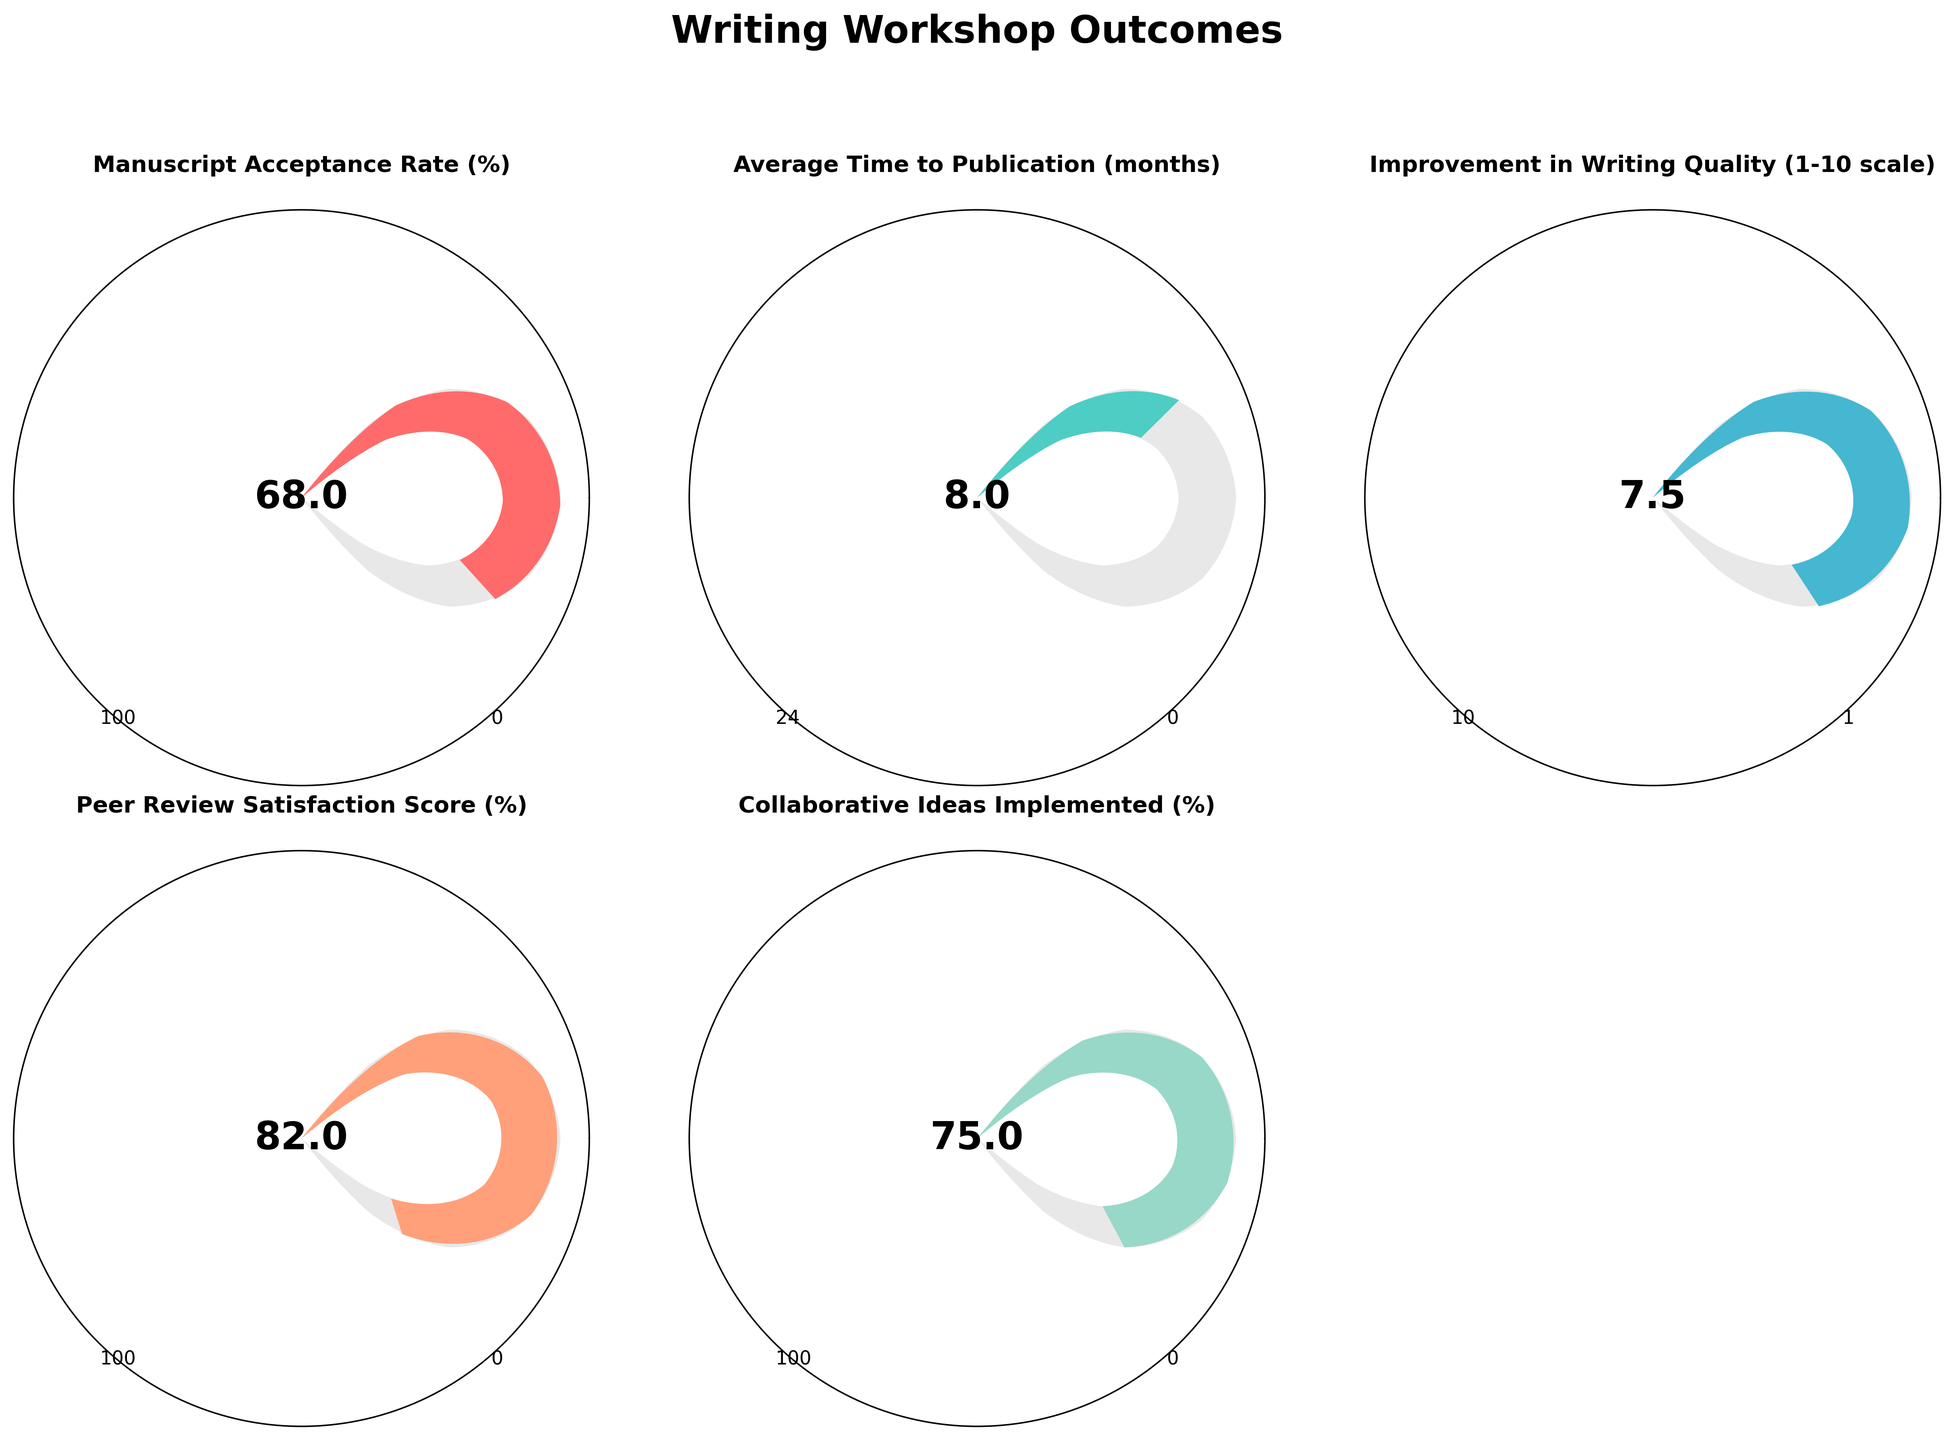Which metric has the highest value? By examining the gauge charts, the Peer Review Satisfaction Score has the highest value at 82%.
Answer: Peer Review Satisfaction Score How much higher is the Manuscript Acceptance Rate compared to the Collaborative Ideas Implemented? The Manuscript Acceptance Rate is 68%, and the Collaborative Ideas Implemented is 75%. The difference is 75% - 68% = 7%.
Answer: 7% What is the average value of the Manuscript Acceptance Rate and the Peer Review Satisfaction Score? The Manuscript Acceptance Rate is 68%, and the Peer Review Satisfaction Score is 82%. The average is (68 + 82) / 2 = 75%.
Answer: 75% What improvement in writing quality is shown? The gauge chart for Improvement in Writing Quality shows a value of 7.5 on a 1-10 scale.
Answer: 7.5 Which metric shows a value of 8 months? The gauge chart for Average Time to Publication shows 8 months.
Answer: Average Time to Publication Is the Collaborative Ideas Implemented value above or below 70%? The Collaborative Ideas Implemented value is 75%, which is above 70%.
Answer: Above Which metric is closest to its maximum value in percentage terms? Peer Review Satisfaction Score is 82 out of 100, which is 82% of its maximum value. Other metrics have lower percentage values relative to their maximums.
Answer: Peer Review Satisfaction Score How much more is the Peer Review Satisfaction Score than the average value of all other metrics? To find the average value of all other metrics, sum 68% (Manuscript Acceptance Rate) + 8 (Time to Publication scaled to 100 which is 8/24*100=33.33) + 7.5 (Writing Quality scaled to 100 which is 7.5/10*100=75) + 75% (Collaborative Ideas) = 68 + 33.33 + 75 + 75 = 251.33, divide by 4, average = 62.83. Difference is 82 - 62.83 = 19.17%.
Answer: 19.17% What's the range for the Average Time to Publication metric? The minimum value for the Average Time to Publication is 0 months and the maximum value is 24 months.
Answer: 0 to 24 months How does the Improvement in Writing Quality compare to the Manuscript Acceptance Rate in percentage terms? Improvement in Writing Quality is 7.5 on a scale of 1-10, which translates to 75%. Manuscript Acceptance Rate is 68%. Improvement in Writing Quality is 7% higher.
Answer: 7% higher 